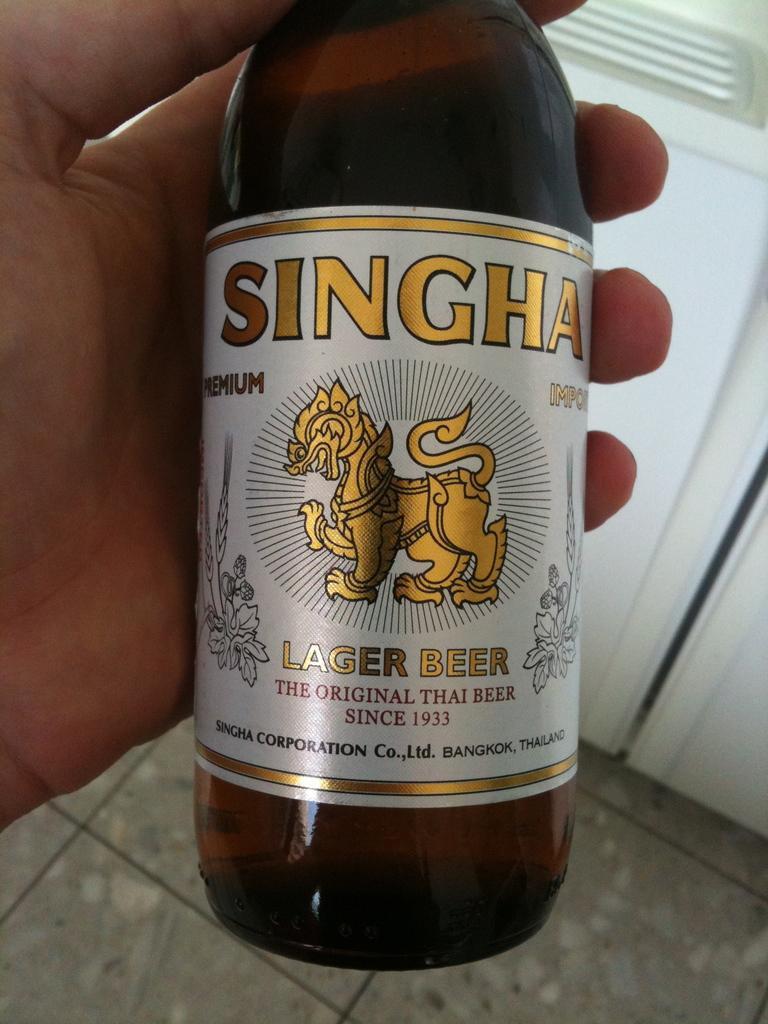Describe this image in one or two sentences. In this image there is a beer bottle is in a person's hand as we can see at middle of this image and there is a wall in the background. 